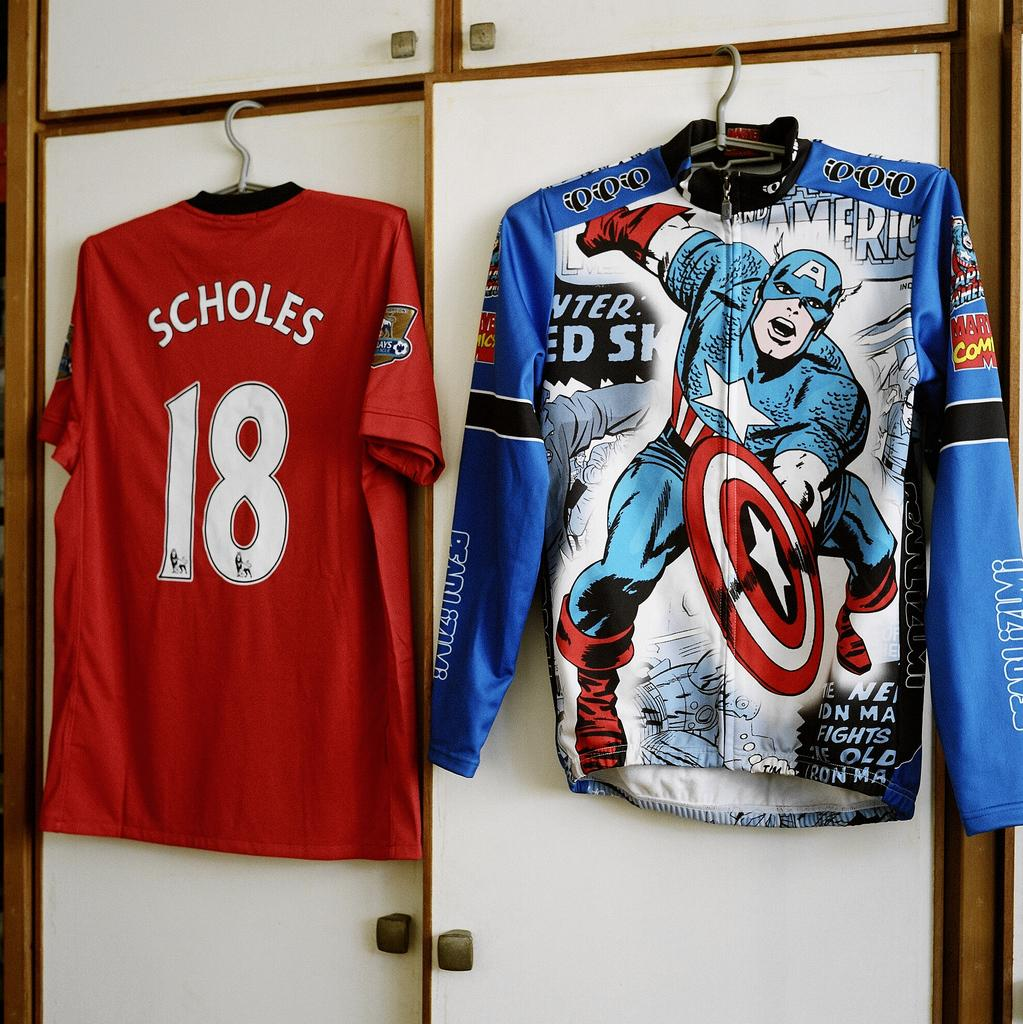Provide a one-sentence caption for the provided image. A red shirt has the number 18 on it and hangs next to another shirt. 